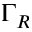<formula> <loc_0><loc_0><loc_500><loc_500>\Gamma _ { R }</formula> 